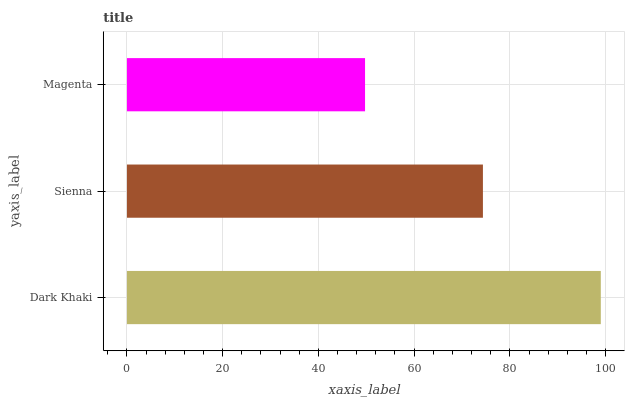Is Magenta the minimum?
Answer yes or no. Yes. Is Dark Khaki the maximum?
Answer yes or no. Yes. Is Sienna the minimum?
Answer yes or no. No. Is Sienna the maximum?
Answer yes or no. No. Is Dark Khaki greater than Sienna?
Answer yes or no. Yes. Is Sienna less than Dark Khaki?
Answer yes or no. Yes. Is Sienna greater than Dark Khaki?
Answer yes or no. No. Is Dark Khaki less than Sienna?
Answer yes or no. No. Is Sienna the high median?
Answer yes or no. Yes. Is Sienna the low median?
Answer yes or no. Yes. Is Magenta the high median?
Answer yes or no. No. Is Magenta the low median?
Answer yes or no. No. 